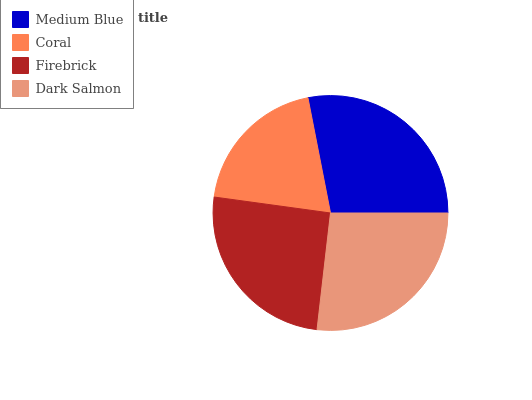Is Coral the minimum?
Answer yes or no. Yes. Is Medium Blue the maximum?
Answer yes or no. Yes. Is Firebrick the minimum?
Answer yes or no. No. Is Firebrick the maximum?
Answer yes or no. No. Is Firebrick greater than Coral?
Answer yes or no. Yes. Is Coral less than Firebrick?
Answer yes or no. Yes. Is Coral greater than Firebrick?
Answer yes or no. No. Is Firebrick less than Coral?
Answer yes or no. No. Is Dark Salmon the high median?
Answer yes or no. Yes. Is Firebrick the low median?
Answer yes or no. Yes. Is Firebrick the high median?
Answer yes or no. No. Is Dark Salmon the low median?
Answer yes or no. No. 